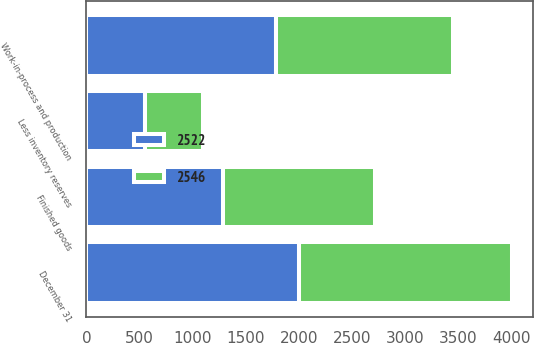Convert chart to OTSL. <chart><loc_0><loc_0><loc_500><loc_500><stacked_bar_chart><ecel><fcel>December 31<fcel>Finished goods<fcel>Work-in-process and production<fcel>Less inventory reserves<nl><fcel>2522<fcel>2005<fcel>1287<fcel>1784<fcel>549<nl><fcel>2546<fcel>2004<fcel>1429<fcel>1665<fcel>548<nl></chart> 